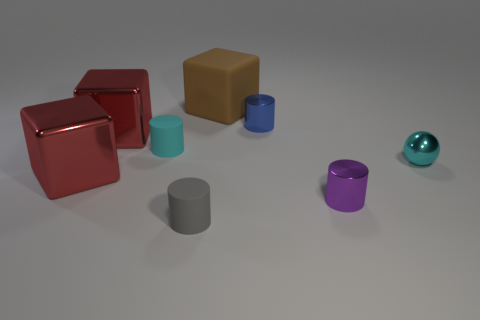There is a matte cube; is it the same color as the shiny cylinder to the left of the purple metal cylinder?
Make the answer very short. No. The cyan cylinder that is made of the same material as the large brown cube is what size?
Ensure brevity in your answer.  Small. Is the number of tiny cyan things that are in front of the sphere greater than the number of small shiny things?
Provide a short and direct response. No. What is the material of the cylinder that is right of the small shiny thing that is left of the tiny cylinder to the right of the small blue metal thing?
Offer a very short reply. Metal. Does the tiny blue cylinder have the same material as the small cyan object that is to the right of the blue metallic object?
Give a very brief answer. Yes. What material is the purple thing that is the same shape as the small blue thing?
Ensure brevity in your answer.  Metal. Are there more tiny cyan metallic things to the left of the tiny gray cylinder than red objects on the right side of the brown rubber cube?
Offer a very short reply. No. What is the shape of the cyan object that is made of the same material as the tiny blue cylinder?
Your answer should be very brief. Sphere. What number of other things are there of the same shape as the purple thing?
Offer a very short reply. 3. What shape is the object behind the blue metallic object?
Your answer should be very brief. Cube. 